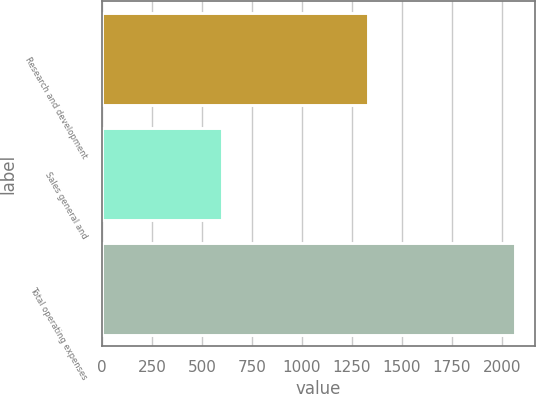Convert chart to OTSL. <chart><loc_0><loc_0><loc_500><loc_500><bar_chart><fcel>Research and development<fcel>Sales general and<fcel>Total operating expenses<nl><fcel>1331<fcel>602<fcel>2064<nl></chart> 